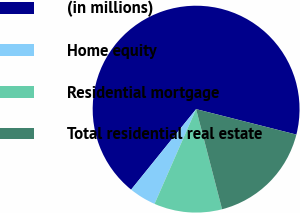Convert chart. <chart><loc_0><loc_0><loc_500><loc_500><pie_chart><fcel>(in millions)<fcel>Home equity<fcel>Residential mortgage<fcel>Total residential real estate<nl><fcel>68.15%<fcel>4.23%<fcel>10.62%<fcel>17.01%<nl></chart> 